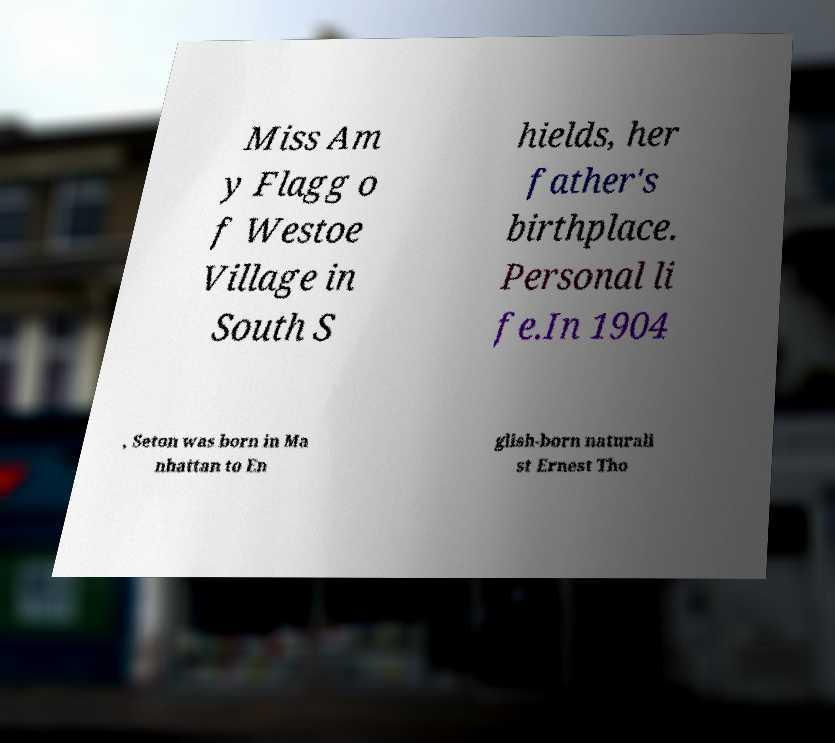Please identify and transcribe the text found in this image. Miss Am y Flagg o f Westoe Village in South S hields, her father's birthplace. Personal li fe.In 1904 , Seton was born in Ma nhattan to En glish-born naturali st Ernest Tho 